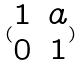<formula> <loc_0><loc_0><loc_500><loc_500>( \begin{matrix} 1 & a \\ 0 & 1 \end{matrix} )</formula> 